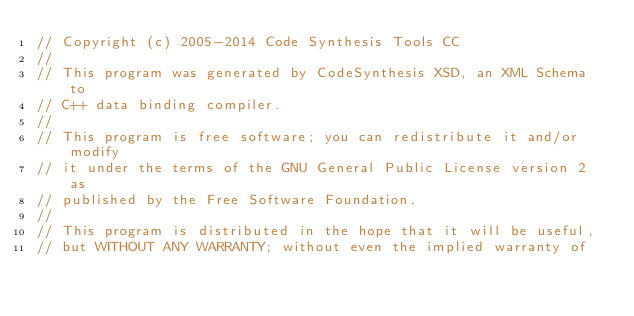<code> <loc_0><loc_0><loc_500><loc_500><_C++_>// Copyright (c) 2005-2014 Code Synthesis Tools CC
//
// This program was generated by CodeSynthesis XSD, an XML Schema to
// C++ data binding compiler.
//
// This program is free software; you can redistribute it and/or modify
// it under the terms of the GNU General Public License version 2 as
// published by the Free Software Foundation.
//
// This program is distributed in the hope that it will be useful,
// but WITHOUT ANY WARRANTY; without even the implied warranty of</code> 